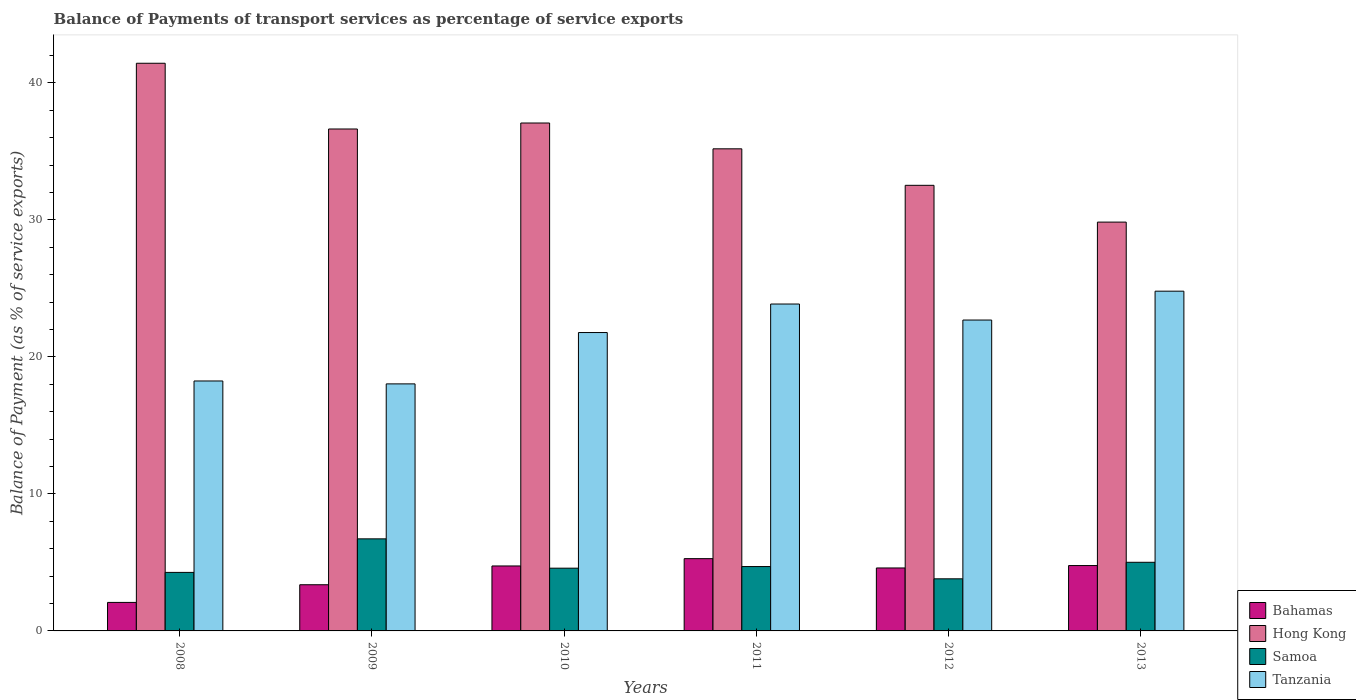Are the number of bars on each tick of the X-axis equal?
Make the answer very short. Yes. How many bars are there on the 2nd tick from the left?
Offer a terse response. 4. What is the balance of payments of transport services in Samoa in 2013?
Your response must be concise. 5.01. Across all years, what is the maximum balance of payments of transport services in Bahamas?
Provide a short and direct response. 5.27. Across all years, what is the minimum balance of payments of transport services in Tanzania?
Make the answer very short. 18.03. In which year was the balance of payments of transport services in Bahamas minimum?
Make the answer very short. 2008. What is the total balance of payments of transport services in Bahamas in the graph?
Keep it short and to the point. 24.83. What is the difference between the balance of payments of transport services in Hong Kong in 2011 and that in 2013?
Provide a succinct answer. 5.35. What is the difference between the balance of payments of transport services in Bahamas in 2010 and the balance of payments of transport services in Tanzania in 2013?
Your answer should be very brief. -20.06. What is the average balance of payments of transport services in Tanzania per year?
Give a very brief answer. 21.57. In the year 2009, what is the difference between the balance of payments of transport services in Hong Kong and balance of payments of transport services in Samoa?
Offer a terse response. 29.91. What is the ratio of the balance of payments of transport services in Tanzania in 2010 to that in 2011?
Make the answer very short. 0.91. Is the difference between the balance of payments of transport services in Hong Kong in 2012 and 2013 greater than the difference between the balance of payments of transport services in Samoa in 2012 and 2013?
Provide a short and direct response. Yes. What is the difference between the highest and the second highest balance of payments of transport services in Samoa?
Keep it short and to the point. 1.71. What is the difference between the highest and the lowest balance of payments of transport services in Bahamas?
Make the answer very short. 3.19. In how many years, is the balance of payments of transport services in Tanzania greater than the average balance of payments of transport services in Tanzania taken over all years?
Your answer should be compact. 4. Is the sum of the balance of payments of transport services in Samoa in 2009 and 2011 greater than the maximum balance of payments of transport services in Bahamas across all years?
Offer a very short reply. Yes. What does the 3rd bar from the left in 2009 represents?
Your answer should be very brief. Samoa. What does the 3rd bar from the right in 2010 represents?
Give a very brief answer. Hong Kong. Is it the case that in every year, the sum of the balance of payments of transport services in Tanzania and balance of payments of transport services in Bahamas is greater than the balance of payments of transport services in Samoa?
Offer a terse response. Yes. What is the difference between two consecutive major ticks on the Y-axis?
Your response must be concise. 10. Does the graph contain grids?
Provide a short and direct response. No. What is the title of the graph?
Your answer should be very brief. Balance of Payments of transport services as percentage of service exports. Does "Uganda" appear as one of the legend labels in the graph?
Offer a very short reply. No. What is the label or title of the Y-axis?
Keep it short and to the point. Balance of Payment (as % of service exports). What is the Balance of Payment (as % of service exports) of Bahamas in 2008?
Ensure brevity in your answer.  2.08. What is the Balance of Payment (as % of service exports) of Hong Kong in 2008?
Ensure brevity in your answer.  41.43. What is the Balance of Payment (as % of service exports) in Samoa in 2008?
Offer a terse response. 4.27. What is the Balance of Payment (as % of service exports) in Tanzania in 2008?
Offer a very short reply. 18.24. What is the Balance of Payment (as % of service exports) in Bahamas in 2009?
Provide a short and direct response. 3.37. What is the Balance of Payment (as % of service exports) of Hong Kong in 2009?
Keep it short and to the point. 36.63. What is the Balance of Payment (as % of service exports) in Samoa in 2009?
Keep it short and to the point. 6.72. What is the Balance of Payment (as % of service exports) in Tanzania in 2009?
Offer a very short reply. 18.03. What is the Balance of Payment (as % of service exports) of Bahamas in 2010?
Provide a short and direct response. 4.74. What is the Balance of Payment (as % of service exports) of Hong Kong in 2010?
Your answer should be compact. 37.07. What is the Balance of Payment (as % of service exports) in Samoa in 2010?
Keep it short and to the point. 4.58. What is the Balance of Payment (as % of service exports) in Tanzania in 2010?
Make the answer very short. 21.78. What is the Balance of Payment (as % of service exports) in Bahamas in 2011?
Your response must be concise. 5.27. What is the Balance of Payment (as % of service exports) of Hong Kong in 2011?
Offer a very short reply. 35.19. What is the Balance of Payment (as % of service exports) in Samoa in 2011?
Make the answer very short. 4.7. What is the Balance of Payment (as % of service exports) of Tanzania in 2011?
Offer a very short reply. 23.86. What is the Balance of Payment (as % of service exports) of Bahamas in 2012?
Provide a short and direct response. 4.59. What is the Balance of Payment (as % of service exports) in Hong Kong in 2012?
Keep it short and to the point. 32.52. What is the Balance of Payment (as % of service exports) of Samoa in 2012?
Your answer should be very brief. 3.8. What is the Balance of Payment (as % of service exports) in Tanzania in 2012?
Your answer should be very brief. 22.69. What is the Balance of Payment (as % of service exports) of Bahamas in 2013?
Keep it short and to the point. 4.77. What is the Balance of Payment (as % of service exports) of Hong Kong in 2013?
Give a very brief answer. 29.84. What is the Balance of Payment (as % of service exports) of Samoa in 2013?
Offer a terse response. 5.01. What is the Balance of Payment (as % of service exports) of Tanzania in 2013?
Provide a short and direct response. 24.8. Across all years, what is the maximum Balance of Payment (as % of service exports) of Bahamas?
Your answer should be very brief. 5.27. Across all years, what is the maximum Balance of Payment (as % of service exports) of Hong Kong?
Give a very brief answer. 41.43. Across all years, what is the maximum Balance of Payment (as % of service exports) in Samoa?
Make the answer very short. 6.72. Across all years, what is the maximum Balance of Payment (as % of service exports) in Tanzania?
Your response must be concise. 24.8. Across all years, what is the minimum Balance of Payment (as % of service exports) in Bahamas?
Provide a short and direct response. 2.08. Across all years, what is the minimum Balance of Payment (as % of service exports) of Hong Kong?
Make the answer very short. 29.84. Across all years, what is the minimum Balance of Payment (as % of service exports) in Samoa?
Ensure brevity in your answer.  3.8. Across all years, what is the minimum Balance of Payment (as % of service exports) in Tanzania?
Provide a short and direct response. 18.03. What is the total Balance of Payment (as % of service exports) in Bahamas in the graph?
Your response must be concise. 24.83. What is the total Balance of Payment (as % of service exports) in Hong Kong in the graph?
Provide a succinct answer. 212.69. What is the total Balance of Payment (as % of service exports) in Samoa in the graph?
Keep it short and to the point. 29.08. What is the total Balance of Payment (as % of service exports) in Tanzania in the graph?
Make the answer very short. 129.4. What is the difference between the Balance of Payment (as % of service exports) in Bahamas in 2008 and that in 2009?
Ensure brevity in your answer.  -1.29. What is the difference between the Balance of Payment (as % of service exports) in Hong Kong in 2008 and that in 2009?
Provide a succinct answer. 4.8. What is the difference between the Balance of Payment (as % of service exports) in Samoa in 2008 and that in 2009?
Provide a short and direct response. -2.45. What is the difference between the Balance of Payment (as % of service exports) of Tanzania in 2008 and that in 2009?
Provide a short and direct response. 0.21. What is the difference between the Balance of Payment (as % of service exports) of Bahamas in 2008 and that in 2010?
Offer a very short reply. -2.66. What is the difference between the Balance of Payment (as % of service exports) of Hong Kong in 2008 and that in 2010?
Ensure brevity in your answer.  4.36. What is the difference between the Balance of Payment (as % of service exports) in Samoa in 2008 and that in 2010?
Your answer should be very brief. -0.31. What is the difference between the Balance of Payment (as % of service exports) in Tanzania in 2008 and that in 2010?
Give a very brief answer. -3.53. What is the difference between the Balance of Payment (as % of service exports) in Bahamas in 2008 and that in 2011?
Your response must be concise. -3.19. What is the difference between the Balance of Payment (as % of service exports) of Hong Kong in 2008 and that in 2011?
Give a very brief answer. 6.25. What is the difference between the Balance of Payment (as % of service exports) of Samoa in 2008 and that in 2011?
Ensure brevity in your answer.  -0.43. What is the difference between the Balance of Payment (as % of service exports) in Tanzania in 2008 and that in 2011?
Ensure brevity in your answer.  -5.62. What is the difference between the Balance of Payment (as % of service exports) of Bahamas in 2008 and that in 2012?
Offer a very short reply. -2.51. What is the difference between the Balance of Payment (as % of service exports) of Hong Kong in 2008 and that in 2012?
Ensure brevity in your answer.  8.91. What is the difference between the Balance of Payment (as % of service exports) in Samoa in 2008 and that in 2012?
Offer a very short reply. 0.47. What is the difference between the Balance of Payment (as % of service exports) in Tanzania in 2008 and that in 2012?
Provide a succinct answer. -4.45. What is the difference between the Balance of Payment (as % of service exports) of Bahamas in 2008 and that in 2013?
Ensure brevity in your answer.  -2.69. What is the difference between the Balance of Payment (as % of service exports) of Hong Kong in 2008 and that in 2013?
Your response must be concise. 11.59. What is the difference between the Balance of Payment (as % of service exports) of Samoa in 2008 and that in 2013?
Offer a terse response. -0.74. What is the difference between the Balance of Payment (as % of service exports) in Tanzania in 2008 and that in 2013?
Your response must be concise. -6.55. What is the difference between the Balance of Payment (as % of service exports) of Bahamas in 2009 and that in 2010?
Provide a short and direct response. -1.37. What is the difference between the Balance of Payment (as % of service exports) in Hong Kong in 2009 and that in 2010?
Keep it short and to the point. -0.44. What is the difference between the Balance of Payment (as % of service exports) in Samoa in 2009 and that in 2010?
Provide a short and direct response. 2.14. What is the difference between the Balance of Payment (as % of service exports) of Tanzania in 2009 and that in 2010?
Your response must be concise. -3.75. What is the difference between the Balance of Payment (as % of service exports) in Bahamas in 2009 and that in 2011?
Your answer should be compact. -1.9. What is the difference between the Balance of Payment (as % of service exports) of Hong Kong in 2009 and that in 2011?
Your answer should be very brief. 1.45. What is the difference between the Balance of Payment (as % of service exports) of Samoa in 2009 and that in 2011?
Offer a terse response. 2.02. What is the difference between the Balance of Payment (as % of service exports) of Tanzania in 2009 and that in 2011?
Make the answer very short. -5.83. What is the difference between the Balance of Payment (as % of service exports) of Bahamas in 2009 and that in 2012?
Offer a terse response. -1.22. What is the difference between the Balance of Payment (as % of service exports) of Hong Kong in 2009 and that in 2012?
Provide a succinct answer. 4.11. What is the difference between the Balance of Payment (as % of service exports) in Samoa in 2009 and that in 2012?
Your response must be concise. 2.92. What is the difference between the Balance of Payment (as % of service exports) in Tanzania in 2009 and that in 2012?
Your answer should be very brief. -4.66. What is the difference between the Balance of Payment (as % of service exports) of Bahamas in 2009 and that in 2013?
Your answer should be very brief. -1.4. What is the difference between the Balance of Payment (as % of service exports) in Hong Kong in 2009 and that in 2013?
Ensure brevity in your answer.  6.8. What is the difference between the Balance of Payment (as % of service exports) of Samoa in 2009 and that in 2013?
Provide a short and direct response. 1.71. What is the difference between the Balance of Payment (as % of service exports) of Tanzania in 2009 and that in 2013?
Ensure brevity in your answer.  -6.77. What is the difference between the Balance of Payment (as % of service exports) of Bahamas in 2010 and that in 2011?
Offer a terse response. -0.53. What is the difference between the Balance of Payment (as % of service exports) of Hong Kong in 2010 and that in 2011?
Your response must be concise. 1.88. What is the difference between the Balance of Payment (as % of service exports) in Samoa in 2010 and that in 2011?
Ensure brevity in your answer.  -0.12. What is the difference between the Balance of Payment (as % of service exports) in Tanzania in 2010 and that in 2011?
Provide a short and direct response. -2.08. What is the difference between the Balance of Payment (as % of service exports) of Bahamas in 2010 and that in 2012?
Provide a succinct answer. 0.15. What is the difference between the Balance of Payment (as % of service exports) in Hong Kong in 2010 and that in 2012?
Offer a very short reply. 4.55. What is the difference between the Balance of Payment (as % of service exports) of Samoa in 2010 and that in 2012?
Keep it short and to the point. 0.78. What is the difference between the Balance of Payment (as % of service exports) in Tanzania in 2010 and that in 2012?
Offer a very short reply. -0.91. What is the difference between the Balance of Payment (as % of service exports) of Bahamas in 2010 and that in 2013?
Keep it short and to the point. -0.03. What is the difference between the Balance of Payment (as % of service exports) of Hong Kong in 2010 and that in 2013?
Give a very brief answer. 7.23. What is the difference between the Balance of Payment (as % of service exports) of Samoa in 2010 and that in 2013?
Provide a short and direct response. -0.43. What is the difference between the Balance of Payment (as % of service exports) in Tanzania in 2010 and that in 2013?
Make the answer very short. -3.02. What is the difference between the Balance of Payment (as % of service exports) of Bahamas in 2011 and that in 2012?
Offer a terse response. 0.68. What is the difference between the Balance of Payment (as % of service exports) of Hong Kong in 2011 and that in 2012?
Provide a succinct answer. 2.66. What is the difference between the Balance of Payment (as % of service exports) in Samoa in 2011 and that in 2012?
Make the answer very short. 0.9. What is the difference between the Balance of Payment (as % of service exports) of Tanzania in 2011 and that in 2012?
Provide a short and direct response. 1.17. What is the difference between the Balance of Payment (as % of service exports) in Bahamas in 2011 and that in 2013?
Give a very brief answer. 0.5. What is the difference between the Balance of Payment (as % of service exports) in Hong Kong in 2011 and that in 2013?
Offer a very short reply. 5.35. What is the difference between the Balance of Payment (as % of service exports) of Samoa in 2011 and that in 2013?
Your response must be concise. -0.31. What is the difference between the Balance of Payment (as % of service exports) in Tanzania in 2011 and that in 2013?
Provide a succinct answer. -0.94. What is the difference between the Balance of Payment (as % of service exports) in Bahamas in 2012 and that in 2013?
Offer a very short reply. -0.18. What is the difference between the Balance of Payment (as % of service exports) of Hong Kong in 2012 and that in 2013?
Provide a succinct answer. 2.68. What is the difference between the Balance of Payment (as % of service exports) of Samoa in 2012 and that in 2013?
Your response must be concise. -1.21. What is the difference between the Balance of Payment (as % of service exports) of Tanzania in 2012 and that in 2013?
Your response must be concise. -2.11. What is the difference between the Balance of Payment (as % of service exports) in Bahamas in 2008 and the Balance of Payment (as % of service exports) in Hong Kong in 2009?
Offer a very short reply. -34.55. What is the difference between the Balance of Payment (as % of service exports) in Bahamas in 2008 and the Balance of Payment (as % of service exports) in Samoa in 2009?
Your response must be concise. -4.64. What is the difference between the Balance of Payment (as % of service exports) in Bahamas in 2008 and the Balance of Payment (as % of service exports) in Tanzania in 2009?
Your answer should be very brief. -15.95. What is the difference between the Balance of Payment (as % of service exports) of Hong Kong in 2008 and the Balance of Payment (as % of service exports) of Samoa in 2009?
Keep it short and to the point. 34.71. What is the difference between the Balance of Payment (as % of service exports) of Hong Kong in 2008 and the Balance of Payment (as % of service exports) of Tanzania in 2009?
Your response must be concise. 23.4. What is the difference between the Balance of Payment (as % of service exports) in Samoa in 2008 and the Balance of Payment (as % of service exports) in Tanzania in 2009?
Your response must be concise. -13.76. What is the difference between the Balance of Payment (as % of service exports) in Bahamas in 2008 and the Balance of Payment (as % of service exports) in Hong Kong in 2010?
Make the answer very short. -34.99. What is the difference between the Balance of Payment (as % of service exports) of Bahamas in 2008 and the Balance of Payment (as % of service exports) of Samoa in 2010?
Offer a very short reply. -2.5. What is the difference between the Balance of Payment (as % of service exports) in Bahamas in 2008 and the Balance of Payment (as % of service exports) in Tanzania in 2010?
Make the answer very short. -19.7. What is the difference between the Balance of Payment (as % of service exports) of Hong Kong in 2008 and the Balance of Payment (as % of service exports) of Samoa in 2010?
Keep it short and to the point. 36.85. What is the difference between the Balance of Payment (as % of service exports) in Hong Kong in 2008 and the Balance of Payment (as % of service exports) in Tanzania in 2010?
Provide a short and direct response. 19.65. What is the difference between the Balance of Payment (as % of service exports) in Samoa in 2008 and the Balance of Payment (as % of service exports) in Tanzania in 2010?
Offer a terse response. -17.51. What is the difference between the Balance of Payment (as % of service exports) in Bahamas in 2008 and the Balance of Payment (as % of service exports) in Hong Kong in 2011?
Offer a very short reply. -33.11. What is the difference between the Balance of Payment (as % of service exports) of Bahamas in 2008 and the Balance of Payment (as % of service exports) of Samoa in 2011?
Ensure brevity in your answer.  -2.62. What is the difference between the Balance of Payment (as % of service exports) of Bahamas in 2008 and the Balance of Payment (as % of service exports) of Tanzania in 2011?
Your answer should be compact. -21.78. What is the difference between the Balance of Payment (as % of service exports) in Hong Kong in 2008 and the Balance of Payment (as % of service exports) in Samoa in 2011?
Your answer should be compact. 36.73. What is the difference between the Balance of Payment (as % of service exports) of Hong Kong in 2008 and the Balance of Payment (as % of service exports) of Tanzania in 2011?
Provide a succinct answer. 17.57. What is the difference between the Balance of Payment (as % of service exports) in Samoa in 2008 and the Balance of Payment (as % of service exports) in Tanzania in 2011?
Offer a very short reply. -19.59. What is the difference between the Balance of Payment (as % of service exports) in Bahamas in 2008 and the Balance of Payment (as % of service exports) in Hong Kong in 2012?
Your response must be concise. -30.44. What is the difference between the Balance of Payment (as % of service exports) in Bahamas in 2008 and the Balance of Payment (as % of service exports) in Samoa in 2012?
Provide a succinct answer. -1.72. What is the difference between the Balance of Payment (as % of service exports) of Bahamas in 2008 and the Balance of Payment (as % of service exports) of Tanzania in 2012?
Offer a terse response. -20.61. What is the difference between the Balance of Payment (as % of service exports) of Hong Kong in 2008 and the Balance of Payment (as % of service exports) of Samoa in 2012?
Provide a short and direct response. 37.63. What is the difference between the Balance of Payment (as % of service exports) of Hong Kong in 2008 and the Balance of Payment (as % of service exports) of Tanzania in 2012?
Ensure brevity in your answer.  18.74. What is the difference between the Balance of Payment (as % of service exports) in Samoa in 2008 and the Balance of Payment (as % of service exports) in Tanzania in 2012?
Make the answer very short. -18.42. What is the difference between the Balance of Payment (as % of service exports) in Bahamas in 2008 and the Balance of Payment (as % of service exports) in Hong Kong in 2013?
Keep it short and to the point. -27.76. What is the difference between the Balance of Payment (as % of service exports) in Bahamas in 2008 and the Balance of Payment (as % of service exports) in Samoa in 2013?
Provide a succinct answer. -2.93. What is the difference between the Balance of Payment (as % of service exports) in Bahamas in 2008 and the Balance of Payment (as % of service exports) in Tanzania in 2013?
Make the answer very short. -22.72. What is the difference between the Balance of Payment (as % of service exports) of Hong Kong in 2008 and the Balance of Payment (as % of service exports) of Samoa in 2013?
Your answer should be very brief. 36.42. What is the difference between the Balance of Payment (as % of service exports) in Hong Kong in 2008 and the Balance of Payment (as % of service exports) in Tanzania in 2013?
Give a very brief answer. 16.64. What is the difference between the Balance of Payment (as % of service exports) of Samoa in 2008 and the Balance of Payment (as % of service exports) of Tanzania in 2013?
Make the answer very short. -20.53. What is the difference between the Balance of Payment (as % of service exports) of Bahamas in 2009 and the Balance of Payment (as % of service exports) of Hong Kong in 2010?
Your answer should be very brief. -33.7. What is the difference between the Balance of Payment (as % of service exports) of Bahamas in 2009 and the Balance of Payment (as % of service exports) of Samoa in 2010?
Offer a terse response. -1.21. What is the difference between the Balance of Payment (as % of service exports) in Bahamas in 2009 and the Balance of Payment (as % of service exports) in Tanzania in 2010?
Provide a succinct answer. -18.41. What is the difference between the Balance of Payment (as % of service exports) of Hong Kong in 2009 and the Balance of Payment (as % of service exports) of Samoa in 2010?
Give a very brief answer. 32.05. What is the difference between the Balance of Payment (as % of service exports) in Hong Kong in 2009 and the Balance of Payment (as % of service exports) in Tanzania in 2010?
Your answer should be compact. 14.86. What is the difference between the Balance of Payment (as % of service exports) in Samoa in 2009 and the Balance of Payment (as % of service exports) in Tanzania in 2010?
Your answer should be very brief. -15.06. What is the difference between the Balance of Payment (as % of service exports) of Bahamas in 2009 and the Balance of Payment (as % of service exports) of Hong Kong in 2011?
Your answer should be compact. -31.82. What is the difference between the Balance of Payment (as % of service exports) in Bahamas in 2009 and the Balance of Payment (as % of service exports) in Samoa in 2011?
Your response must be concise. -1.33. What is the difference between the Balance of Payment (as % of service exports) of Bahamas in 2009 and the Balance of Payment (as % of service exports) of Tanzania in 2011?
Ensure brevity in your answer.  -20.49. What is the difference between the Balance of Payment (as % of service exports) of Hong Kong in 2009 and the Balance of Payment (as % of service exports) of Samoa in 2011?
Provide a succinct answer. 31.94. What is the difference between the Balance of Payment (as % of service exports) of Hong Kong in 2009 and the Balance of Payment (as % of service exports) of Tanzania in 2011?
Ensure brevity in your answer.  12.78. What is the difference between the Balance of Payment (as % of service exports) in Samoa in 2009 and the Balance of Payment (as % of service exports) in Tanzania in 2011?
Your answer should be very brief. -17.14. What is the difference between the Balance of Payment (as % of service exports) of Bahamas in 2009 and the Balance of Payment (as % of service exports) of Hong Kong in 2012?
Give a very brief answer. -29.15. What is the difference between the Balance of Payment (as % of service exports) of Bahamas in 2009 and the Balance of Payment (as % of service exports) of Samoa in 2012?
Offer a terse response. -0.43. What is the difference between the Balance of Payment (as % of service exports) in Bahamas in 2009 and the Balance of Payment (as % of service exports) in Tanzania in 2012?
Provide a succinct answer. -19.32. What is the difference between the Balance of Payment (as % of service exports) of Hong Kong in 2009 and the Balance of Payment (as % of service exports) of Samoa in 2012?
Make the answer very short. 32.83. What is the difference between the Balance of Payment (as % of service exports) in Hong Kong in 2009 and the Balance of Payment (as % of service exports) in Tanzania in 2012?
Your answer should be compact. 13.94. What is the difference between the Balance of Payment (as % of service exports) of Samoa in 2009 and the Balance of Payment (as % of service exports) of Tanzania in 2012?
Provide a succinct answer. -15.97. What is the difference between the Balance of Payment (as % of service exports) in Bahamas in 2009 and the Balance of Payment (as % of service exports) in Hong Kong in 2013?
Your response must be concise. -26.47. What is the difference between the Balance of Payment (as % of service exports) in Bahamas in 2009 and the Balance of Payment (as % of service exports) in Samoa in 2013?
Provide a short and direct response. -1.64. What is the difference between the Balance of Payment (as % of service exports) in Bahamas in 2009 and the Balance of Payment (as % of service exports) in Tanzania in 2013?
Provide a short and direct response. -21.43. What is the difference between the Balance of Payment (as % of service exports) of Hong Kong in 2009 and the Balance of Payment (as % of service exports) of Samoa in 2013?
Your answer should be very brief. 31.63. What is the difference between the Balance of Payment (as % of service exports) in Hong Kong in 2009 and the Balance of Payment (as % of service exports) in Tanzania in 2013?
Keep it short and to the point. 11.84. What is the difference between the Balance of Payment (as % of service exports) of Samoa in 2009 and the Balance of Payment (as % of service exports) of Tanzania in 2013?
Provide a succinct answer. -18.08. What is the difference between the Balance of Payment (as % of service exports) of Bahamas in 2010 and the Balance of Payment (as % of service exports) of Hong Kong in 2011?
Provide a succinct answer. -30.45. What is the difference between the Balance of Payment (as % of service exports) in Bahamas in 2010 and the Balance of Payment (as % of service exports) in Samoa in 2011?
Give a very brief answer. 0.04. What is the difference between the Balance of Payment (as % of service exports) of Bahamas in 2010 and the Balance of Payment (as % of service exports) of Tanzania in 2011?
Make the answer very short. -19.12. What is the difference between the Balance of Payment (as % of service exports) in Hong Kong in 2010 and the Balance of Payment (as % of service exports) in Samoa in 2011?
Offer a very short reply. 32.37. What is the difference between the Balance of Payment (as % of service exports) of Hong Kong in 2010 and the Balance of Payment (as % of service exports) of Tanzania in 2011?
Your answer should be compact. 13.21. What is the difference between the Balance of Payment (as % of service exports) in Samoa in 2010 and the Balance of Payment (as % of service exports) in Tanzania in 2011?
Provide a succinct answer. -19.28. What is the difference between the Balance of Payment (as % of service exports) in Bahamas in 2010 and the Balance of Payment (as % of service exports) in Hong Kong in 2012?
Your answer should be very brief. -27.78. What is the difference between the Balance of Payment (as % of service exports) of Bahamas in 2010 and the Balance of Payment (as % of service exports) of Samoa in 2012?
Keep it short and to the point. 0.94. What is the difference between the Balance of Payment (as % of service exports) in Bahamas in 2010 and the Balance of Payment (as % of service exports) in Tanzania in 2012?
Your answer should be very brief. -17.95. What is the difference between the Balance of Payment (as % of service exports) of Hong Kong in 2010 and the Balance of Payment (as % of service exports) of Samoa in 2012?
Make the answer very short. 33.27. What is the difference between the Balance of Payment (as % of service exports) in Hong Kong in 2010 and the Balance of Payment (as % of service exports) in Tanzania in 2012?
Keep it short and to the point. 14.38. What is the difference between the Balance of Payment (as % of service exports) in Samoa in 2010 and the Balance of Payment (as % of service exports) in Tanzania in 2012?
Ensure brevity in your answer.  -18.11. What is the difference between the Balance of Payment (as % of service exports) of Bahamas in 2010 and the Balance of Payment (as % of service exports) of Hong Kong in 2013?
Offer a very short reply. -25.1. What is the difference between the Balance of Payment (as % of service exports) in Bahamas in 2010 and the Balance of Payment (as % of service exports) in Samoa in 2013?
Provide a short and direct response. -0.27. What is the difference between the Balance of Payment (as % of service exports) in Bahamas in 2010 and the Balance of Payment (as % of service exports) in Tanzania in 2013?
Your answer should be very brief. -20.06. What is the difference between the Balance of Payment (as % of service exports) in Hong Kong in 2010 and the Balance of Payment (as % of service exports) in Samoa in 2013?
Provide a short and direct response. 32.06. What is the difference between the Balance of Payment (as % of service exports) in Hong Kong in 2010 and the Balance of Payment (as % of service exports) in Tanzania in 2013?
Your answer should be compact. 12.27. What is the difference between the Balance of Payment (as % of service exports) of Samoa in 2010 and the Balance of Payment (as % of service exports) of Tanzania in 2013?
Make the answer very short. -20.22. What is the difference between the Balance of Payment (as % of service exports) in Bahamas in 2011 and the Balance of Payment (as % of service exports) in Hong Kong in 2012?
Offer a terse response. -27.25. What is the difference between the Balance of Payment (as % of service exports) of Bahamas in 2011 and the Balance of Payment (as % of service exports) of Samoa in 2012?
Provide a short and direct response. 1.47. What is the difference between the Balance of Payment (as % of service exports) in Bahamas in 2011 and the Balance of Payment (as % of service exports) in Tanzania in 2012?
Your answer should be compact. -17.42. What is the difference between the Balance of Payment (as % of service exports) in Hong Kong in 2011 and the Balance of Payment (as % of service exports) in Samoa in 2012?
Ensure brevity in your answer.  31.38. What is the difference between the Balance of Payment (as % of service exports) in Hong Kong in 2011 and the Balance of Payment (as % of service exports) in Tanzania in 2012?
Keep it short and to the point. 12.5. What is the difference between the Balance of Payment (as % of service exports) in Samoa in 2011 and the Balance of Payment (as % of service exports) in Tanzania in 2012?
Offer a very short reply. -17.99. What is the difference between the Balance of Payment (as % of service exports) of Bahamas in 2011 and the Balance of Payment (as % of service exports) of Hong Kong in 2013?
Provide a succinct answer. -24.56. What is the difference between the Balance of Payment (as % of service exports) in Bahamas in 2011 and the Balance of Payment (as % of service exports) in Samoa in 2013?
Provide a short and direct response. 0.27. What is the difference between the Balance of Payment (as % of service exports) in Bahamas in 2011 and the Balance of Payment (as % of service exports) in Tanzania in 2013?
Make the answer very short. -19.52. What is the difference between the Balance of Payment (as % of service exports) of Hong Kong in 2011 and the Balance of Payment (as % of service exports) of Samoa in 2013?
Your answer should be very brief. 30.18. What is the difference between the Balance of Payment (as % of service exports) in Hong Kong in 2011 and the Balance of Payment (as % of service exports) in Tanzania in 2013?
Your response must be concise. 10.39. What is the difference between the Balance of Payment (as % of service exports) in Samoa in 2011 and the Balance of Payment (as % of service exports) in Tanzania in 2013?
Your answer should be very brief. -20.1. What is the difference between the Balance of Payment (as % of service exports) of Bahamas in 2012 and the Balance of Payment (as % of service exports) of Hong Kong in 2013?
Your response must be concise. -25.24. What is the difference between the Balance of Payment (as % of service exports) of Bahamas in 2012 and the Balance of Payment (as % of service exports) of Samoa in 2013?
Your answer should be very brief. -0.41. What is the difference between the Balance of Payment (as % of service exports) of Bahamas in 2012 and the Balance of Payment (as % of service exports) of Tanzania in 2013?
Your response must be concise. -20.2. What is the difference between the Balance of Payment (as % of service exports) in Hong Kong in 2012 and the Balance of Payment (as % of service exports) in Samoa in 2013?
Provide a succinct answer. 27.51. What is the difference between the Balance of Payment (as % of service exports) of Hong Kong in 2012 and the Balance of Payment (as % of service exports) of Tanzania in 2013?
Your answer should be very brief. 7.73. What is the difference between the Balance of Payment (as % of service exports) of Samoa in 2012 and the Balance of Payment (as % of service exports) of Tanzania in 2013?
Your response must be concise. -20.99. What is the average Balance of Payment (as % of service exports) in Bahamas per year?
Provide a succinct answer. 4.14. What is the average Balance of Payment (as % of service exports) in Hong Kong per year?
Your answer should be very brief. 35.45. What is the average Balance of Payment (as % of service exports) of Samoa per year?
Your answer should be very brief. 4.85. What is the average Balance of Payment (as % of service exports) of Tanzania per year?
Provide a short and direct response. 21.57. In the year 2008, what is the difference between the Balance of Payment (as % of service exports) of Bahamas and Balance of Payment (as % of service exports) of Hong Kong?
Your response must be concise. -39.35. In the year 2008, what is the difference between the Balance of Payment (as % of service exports) in Bahamas and Balance of Payment (as % of service exports) in Samoa?
Provide a succinct answer. -2.19. In the year 2008, what is the difference between the Balance of Payment (as % of service exports) in Bahamas and Balance of Payment (as % of service exports) in Tanzania?
Give a very brief answer. -16.16. In the year 2008, what is the difference between the Balance of Payment (as % of service exports) in Hong Kong and Balance of Payment (as % of service exports) in Samoa?
Provide a short and direct response. 37.16. In the year 2008, what is the difference between the Balance of Payment (as % of service exports) of Hong Kong and Balance of Payment (as % of service exports) of Tanzania?
Your response must be concise. 23.19. In the year 2008, what is the difference between the Balance of Payment (as % of service exports) of Samoa and Balance of Payment (as % of service exports) of Tanzania?
Offer a terse response. -13.97. In the year 2009, what is the difference between the Balance of Payment (as % of service exports) of Bahamas and Balance of Payment (as % of service exports) of Hong Kong?
Your answer should be compact. -33.26. In the year 2009, what is the difference between the Balance of Payment (as % of service exports) in Bahamas and Balance of Payment (as % of service exports) in Samoa?
Your answer should be very brief. -3.35. In the year 2009, what is the difference between the Balance of Payment (as % of service exports) of Bahamas and Balance of Payment (as % of service exports) of Tanzania?
Your response must be concise. -14.66. In the year 2009, what is the difference between the Balance of Payment (as % of service exports) of Hong Kong and Balance of Payment (as % of service exports) of Samoa?
Provide a short and direct response. 29.91. In the year 2009, what is the difference between the Balance of Payment (as % of service exports) of Hong Kong and Balance of Payment (as % of service exports) of Tanzania?
Your response must be concise. 18.6. In the year 2009, what is the difference between the Balance of Payment (as % of service exports) of Samoa and Balance of Payment (as % of service exports) of Tanzania?
Make the answer very short. -11.31. In the year 2010, what is the difference between the Balance of Payment (as % of service exports) of Bahamas and Balance of Payment (as % of service exports) of Hong Kong?
Your answer should be very brief. -32.33. In the year 2010, what is the difference between the Balance of Payment (as % of service exports) in Bahamas and Balance of Payment (as % of service exports) in Samoa?
Your response must be concise. 0.16. In the year 2010, what is the difference between the Balance of Payment (as % of service exports) in Bahamas and Balance of Payment (as % of service exports) in Tanzania?
Offer a very short reply. -17.04. In the year 2010, what is the difference between the Balance of Payment (as % of service exports) of Hong Kong and Balance of Payment (as % of service exports) of Samoa?
Provide a succinct answer. 32.49. In the year 2010, what is the difference between the Balance of Payment (as % of service exports) in Hong Kong and Balance of Payment (as % of service exports) in Tanzania?
Provide a short and direct response. 15.29. In the year 2010, what is the difference between the Balance of Payment (as % of service exports) of Samoa and Balance of Payment (as % of service exports) of Tanzania?
Provide a succinct answer. -17.2. In the year 2011, what is the difference between the Balance of Payment (as % of service exports) in Bahamas and Balance of Payment (as % of service exports) in Hong Kong?
Ensure brevity in your answer.  -29.91. In the year 2011, what is the difference between the Balance of Payment (as % of service exports) in Bahamas and Balance of Payment (as % of service exports) in Samoa?
Your answer should be very brief. 0.58. In the year 2011, what is the difference between the Balance of Payment (as % of service exports) of Bahamas and Balance of Payment (as % of service exports) of Tanzania?
Your response must be concise. -18.58. In the year 2011, what is the difference between the Balance of Payment (as % of service exports) of Hong Kong and Balance of Payment (as % of service exports) of Samoa?
Provide a short and direct response. 30.49. In the year 2011, what is the difference between the Balance of Payment (as % of service exports) in Hong Kong and Balance of Payment (as % of service exports) in Tanzania?
Provide a short and direct response. 11.33. In the year 2011, what is the difference between the Balance of Payment (as % of service exports) of Samoa and Balance of Payment (as % of service exports) of Tanzania?
Make the answer very short. -19.16. In the year 2012, what is the difference between the Balance of Payment (as % of service exports) in Bahamas and Balance of Payment (as % of service exports) in Hong Kong?
Offer a very short reply. -27.93. In the year 2012, what is the difference between the Balance of Payment (as % of service exports) of Bahamas and Balance of Payment (as % of service exports) of Samoa?
Offer a terse response. 0.79. In the year 2012, what is the difference between the Balance of Payment (as % of service exports) in Bahamas and Balance of Payment (as % of service exports) in Tanzania?
Your response must be concise. -18.1. In the year 2012, what is the difference between the Balance of Payment (as % of service exports) in Hong Kong and Balance of Payment (as % of service exports) in Samoa?
Make the answer very short. 28.72. In the year 2012, what is the difference between the Balance of Payment (as % of service exports) of Hong Kong and Balance of Payment (as % of service exports) of Tanzania?
Give a very brief answer. 9.83. In the year 2012, what is the difference between the Balance of Payment (as % of service exports) in Samoa and Balance of Payment (as % of service exports) in Tanzania?
Offer a terse response. -18.89. In the year 2013, what is the difference between the Balance of Payment (as % of service exports) in Bahamas and Balance of Payment (as % of service exports) in Hong Kong?
Give a very brief answer. -25.07. In the year 2013, what is the difference between the Balance of Payment (as % of service exports) of Bahamas and Balance of Payment (as % of service exports) of Samoa?
Ensure brevity in your answer.  -0.24. In the year 2013, what is the difference between the Balance of Payment (as % of service exports) in Bahamas and Balance of Payment (as % of service exports) in Tanzania?
Your answer should be compact. -20.03. In the year 2013, what is the difference between the Balance of Payment (as % of service exports) in Hong Kong and Balance of Payment (as % of service exports) in Samoa?
Offer a terse response. 24.83. In the year 2013, what is the difference between the Balance of Payment (as % of service exports) of Hong Kong and Balance of Payment (as % of service exports) of Tanzania?
Ensure brevity in your answer.  5.04. In the year 2013, what is the difference between the Balance of Payment (as % of service exports) in Samoa and Balance of Payment (as % of service exports) in Tanzania?
Offer a terse response. -19.79. What is the ratio of the Balance of Payment (as % of service exports) in Bahamas in 2008 to that in 2009?
Give a very brief answer. 0.62. What is the ratio of the Balance of Payment (as % of service exports) in Hong Kong in 2008 to that in 2009?
Ensure brevity in your answer.  1.13. What is the ratio of the Balance of Payment (as % of service exports) of Samoa in 2008 to that in 2009?
Keep it short and to the point. 0.64. What is the ratio of the Balance of Payment (as % of service exports) of Tanzania in 2008 to that in 2009?
Provide a succinct answer. 1.01. What is the ratio of the Balance of Payment (as % of service exports) of Bahamas in 2008 to that in 2010?
Your answer should be very brief. 0.44. What is the ratio of the Balance of Payment (as % of service exports) in Hong Kong in 2008 to that in 2010?
Your answer should be compact. 1.12. What is the ratio of the Balance of Payment (as % of service exports) in Samoa in 2008 to that in 2010?
Your response must be concise. 0.93. What is the ratio of the Balance of Payment (as % of service exports) of Tanzania in 2008 to that in 2010?
Your response must be concise. 0.84. What is the ratio of the Balance of Payment (as % of service exports) of Bahamas in 2008 to that in 2011?
Offer a terse response. 0.39. What is the ratio of the Balance of Payment (as % of service exports) in Hong Kong in 2008 to that in 2011?
Provide a short and direct response. 1.18. What is the ratio of the Balance of Payment (as % of service exports) of Samoa in 2008 to that in 2011?
Your answer should be compact. 0.91. What is the ratio of the Balance of Payment (as % of service exports) in Tanzania in 2008 to that in 2011?
Give a very brief answer. 0.76. What is the ratio of the Balance of Payment (as % of service exports) in Bahamas in 2008 to that in 2012?
Give a very brief answer. 0.45. What is the ratio of the Balance of Payment (as % of service exports) in Hong Kong in 2008 to that in 2012?
Give a very brief answer. 1.27. What is the ratio of the Balance of Payment (as % of service exports) of Samoa in 2008 to that in 2012?
Offer a very short reply. 1.12. What is the ratio of the Balance of Payment (as % of service exports) of Tanzania in 2008 to that in 2012?
Your answer should be very brief. 0.8. What is the ratio of the Balance of Payment (as % of service exports) of Bahamas in 2008 to that in 2013?
Give a very brief answer. 0.44. What is the ratio of the Balance of Payment (as % of service exports) of Hong Kong in 2008 to that in 2013?
Your answer should be very brief. 1.39. What is the ratio of the Balance of Payment (as % of service exports) of Samoa in 2008 to that in 2013?
Make the answer very short. 0.85. What is the ratio of the Balance of Payment (as % of service exports) of Tanzania in 2008 to that in 2013?
Your answer should be very brief. 0.74. What is the ratio of the Balance of Payment (as % of service exports) of Bahamas in 2009 to that in 2010?
Make the answer very short. 0.71. What is the ratio of the Balance of Payment (as % of service exports) in Samoa in 2009 to that in 2010?
Your answer should be compact. 1.47. What is the ratio of the Balance of Payment (as % of service exports) of Tanzania in 2009 to that in 2010?
Make the answer very short. 0.83. What is the ratio of the Balance of Payment (as % of service exports) in Bahamas in 2009 to that in 2011?
Offer a very short reply. 0.64. What is the ratio of the Balance of Payment (as % of service exports) of Hong Kong in 2009 to that in 2011?
Your answer should be compact. 1.04. What is the ratio of the Balance of Payment (as % of service exports) of Samoa in 2009 to that in 2011?
Give a very brief answer. 1.43. What is the ratio of the Balance of Payment (as % of service exports) in Tanzania in 2009 to that in 2011?
Ensure brevity in your answer.  0.76. What is the ratio of the Balance of Payment (as % of service exports) of Bahamas in 2009 to that in 2012?
Provide a succinct answer. 0.73. What is the ratio of the Balance of Payment (as % of service exports) of Hong Kong in 2009 to that in 2012?
Make the answer very short. 1.13. What is the ratio of the Balance of Payment (as % of service exports) in Samoa in 2009 to that in 2012?
Your answer should be very brief. 1.77. What is the ratio of the Balance of Payment (as % of service exports) of Tanzania in 2009 to that in 2012?
Your answer should be compact. 0.79. What is the ratio of the Balance of Payment (as % of service exports) of Bahamas in 2009 to that in 2013?
Provide a succinct answer. 0.71. What is the ratio of the Balance of Payment (as % of service exports) in Hong Kong in 2009 to that in 2013?
Your answer should be very brief. 1.23. What is the ratio of the Balance of Payment (as % of service exports) of Samoa in 2009 to that in 2013?
Give a very brief answer. 1.34. What is the ratio of the Balance of Payment (as % of service exports) in Tanzania in 2009 to that in 2013?
Your answer should be compact. 0.73. What is the ratio of the Balance of Payment (as % of service exports) in Bahamas in 2010 to that in 2011?
Offer a terse response. 0.9. What is the ratio of the Balance of Payment (as % of service exports) in Hong Kong in 2010 to that in 2011?
Offer a terse response. 1.05. What is the ratio of the Balance of Payment (as % of service exports) of Samoa in 2010 to that in 2011?
Ensure brevity in your answer.  0.97. What is the ratio of the Balance of Payment (as % of service exports) of Tanzania in 2010 to that in 2011?
Offer a terse response. 0.91. What is the ratio of the Balance of Payment (as % of service exports) in Bahamas in 2010 to that in 2012?
Your answer should be compact. 1.03. What is the ratio of the Balance of Payment (as % of service exports) of Hong Kong in 2010 to that in 2012?
Ensure brevity in your answer.  1.14. What is the ratio of the Balance of Payment (as % of service exports) of Samoa in 2010 to that in 2012?
Offer a very short reply. 1.2. What is the ratio of the Balance of Payment (as % of service exports) of Tanzania in 2010 to that in 2012?
Give a very brief answer. 0.96. What is the ratio of the Balance of Payment (as % of service exports) of Hong Kong in 2010 to that in 2013?
Your response must be concise. 1.24. What is the ratio of the Balance of Payment (as % of service exports) in Samoa in 2010 to that in 2013?
Your answer should be compact. 0.91. What is the ratio of the Balance of Payment (as % of service exports) of Tanzania in 2010 to that in 2013?
Provide a succinct answer. 0.88. What is the ratio of the Balance of Payment (as % of service exports) of Bahamas in 2011 to that in 2012?
Offer a very short reply. 1.15. What is the ratio of the Balance of Payment (as % of service exports) in Hong Kong in 2011 to that in 2012?
Ensure brevity in your answer.  1.08. What is the ratio of the Balance of Payment (as % of service exports) of Samoa in 2011 to that in 2012?
Offer a terse response. 1.24. What is the ratio of the Balance of Payment (as % of service exports) of Tanzania in 2011 to that in 2012?
Offer a very short reply. 1.05. What is the ratio of the Balance of Payment (as % of service exports) of Bahamas in 2011 to that in 2013?
Your answer should be compact. 1.11. What is the ratio of the Balance of Payment (as % of service exports) of Hong Kong in 2011 to that in 2013?
Give a very brief answer. 1.18. What is the ratio of the Balance of Payment (as % of service exports) of Samoa in 2011 to that in 2013?
Ensure brevity in your answer.  0.94. What is the ratio of the Balance of Payment (as % of service exports) in Tanzania in 2011 to that in 2013?
Provide a short and direct response. 0.96. What is the ratio of the Balance of Payment (as % of service exports) in Hong Kong in 2012 to that in 2013?
Give a very brief answer. 1.09. What is the ratio of the Balance of Payment (as % of service exports) of Samoa in 2012 to that in 2013?
Provide a succinct answer. 0.76. What is the ratio of the Balance of Payment (as % of service exports) of Tanzania in 2012 to that in 2013?
Ensure brevity in your answer.  0.92. What is the difference between the highest and the second highest Balance of Payment (as % of service exports) of Bahamas?
Keep it short and to the point. 0.5. What is the difference between the highest and the second highest Balance of Payment (as % of service exports) in Hong Kong?
Ensure brevity in your answer.  4.36. What is the difference between the highest and the second highest Balance of Payment (as % of service exports) of Samoa?
Provide a succinct answer. 1.71. What is the difference between the highest and the second highest Balance of Payment (as % of service exports) of Tanzania?
Your response must be concise. 0.94. What is the difference between the highest and the lowest Balance of Payment (as % of service exports) in Bahamas?
Make the answer very short. 3.19. What is the difference between the highest and the lowest Balance of Payment (as % of service exports) in Hong Kong?
Ensure brevity in your answer.  11.59. What is the difference between the highest and the lowest Balance of Payment (as % of service exports) in Samoa?
Keep it short and to the point. 2.92. What is the difference between the highest and the lowest Balance of Payment (as % of service exports) of Tanzania?
Your answer should be very brief. 6.77. 